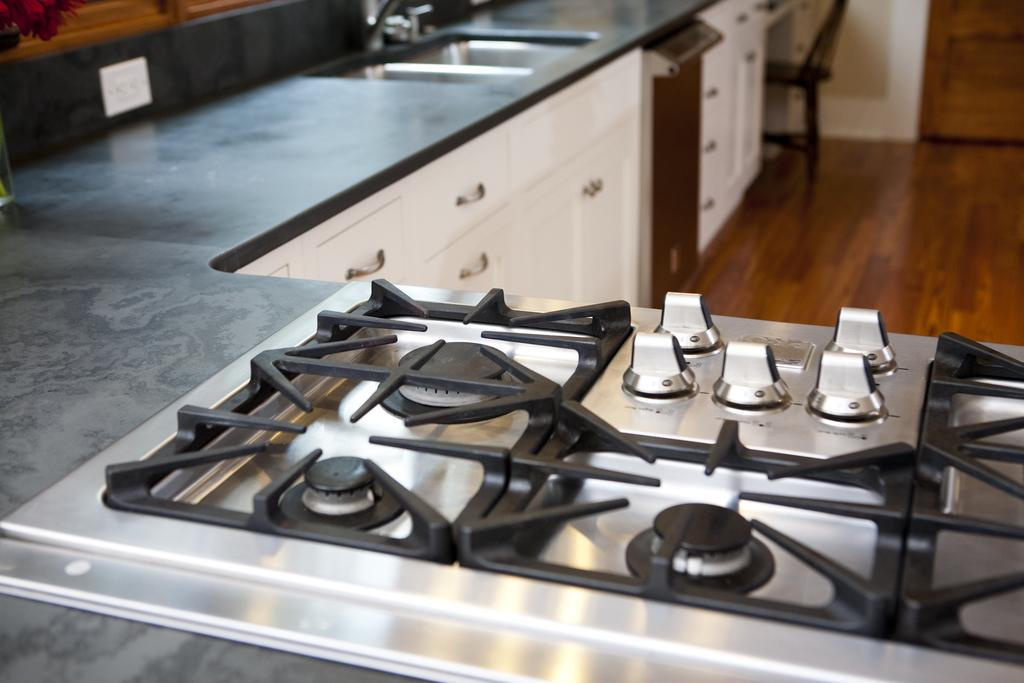What type of appliance is present in the image? There is a stove in the image. What is located near the stove? There is a wash basin in the image. What is below the wash basin? There are cupboards below the wash basin. What type of furniture is in the image? There is a chair in the image. What surface can be seen in the image? There is a wooden surface in the image. What type of rail is present in the image? There is no rail present in the image. Can you describe the sink in the image? There is no sink present in the image; it features a wash basin instead. 